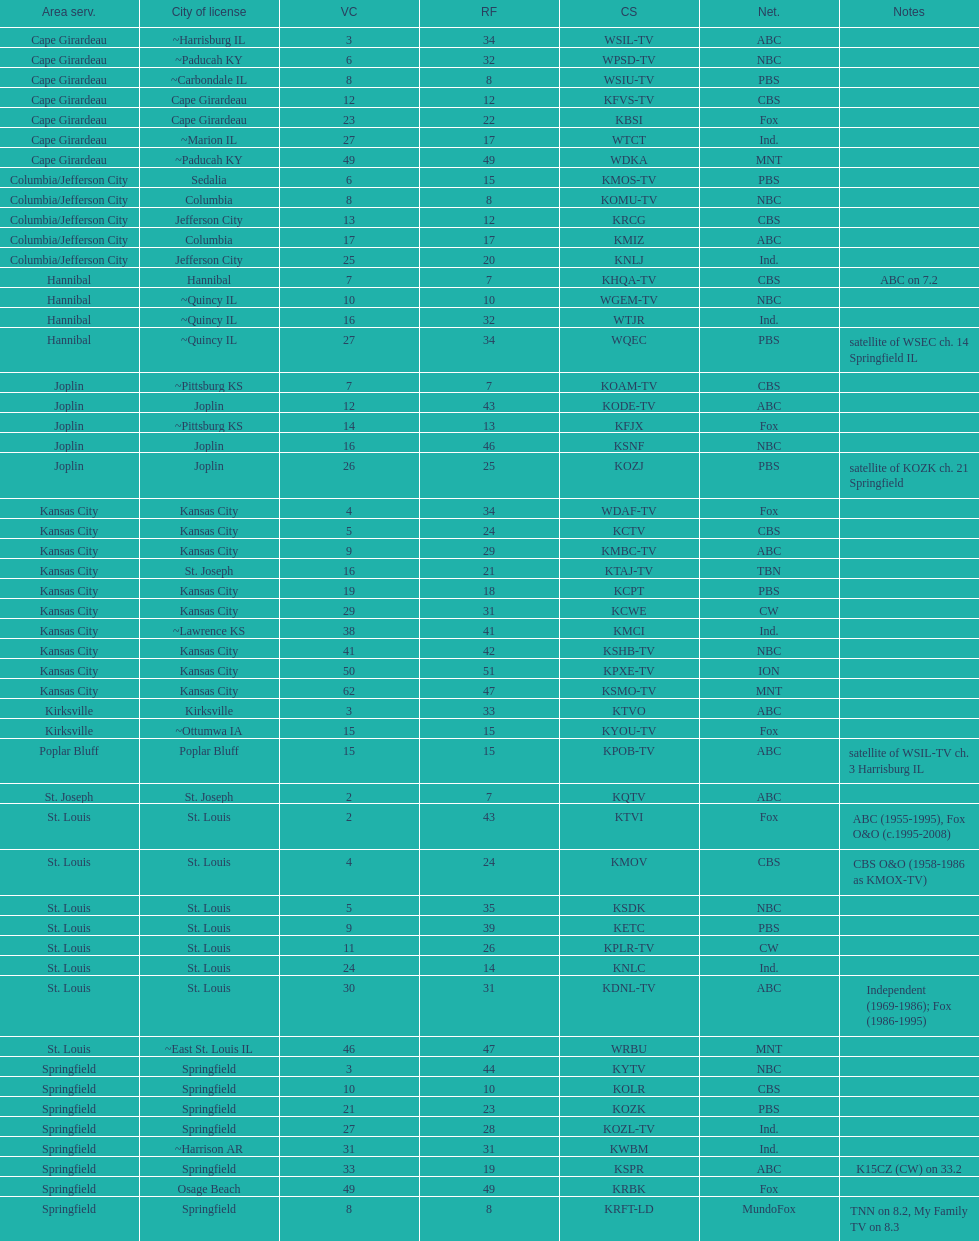What is the total number of stations serving the the cape girardeau area? 7. 